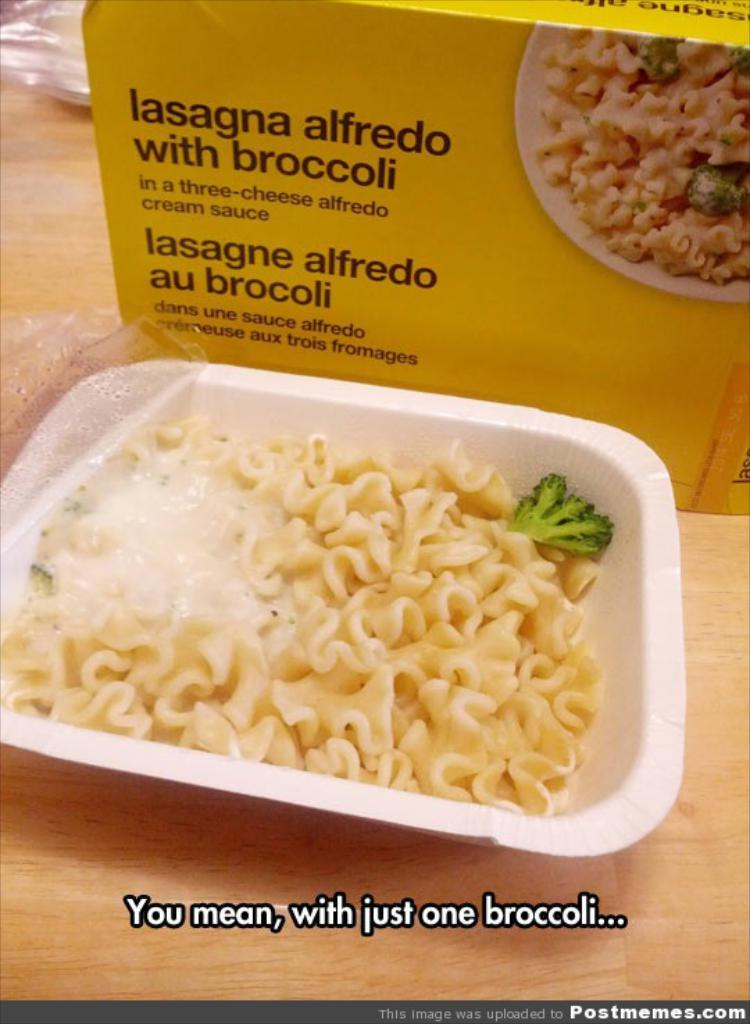What type of furniture is present in the image? There is a table in the image. What is placed on the table? There are bowls on the table. What is inside one of the bowls? There is a dish in one of the bowls. What else can be seen on the table? There is a box on the table. What is written on the box? There is writing on the box. What type of disease is being treated in the image? There is no indication of a disease or treatment in the image. Is there a fire visible in the image? There is no fire present in the image. 